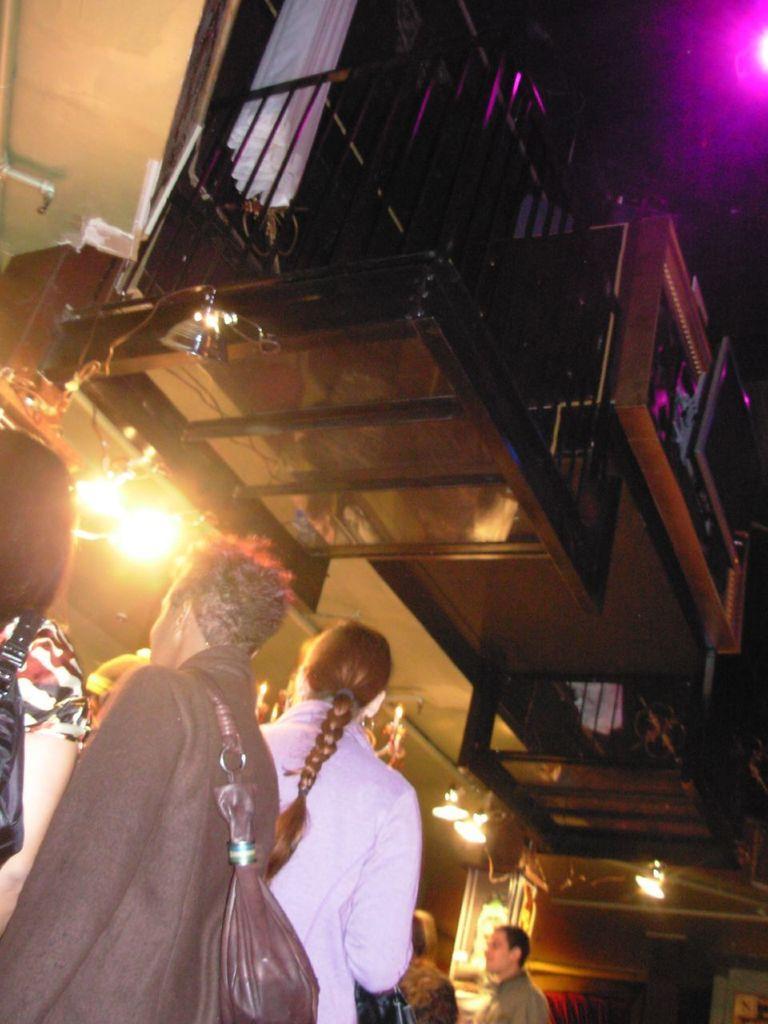In one or two sentences, can you explain what this image depicts? In this image at the bottom there are group of people, some of them are wearing handbags. And in the center there is a building, railing, clothes, lights, and there is black background. On the right side of the image there is light. 